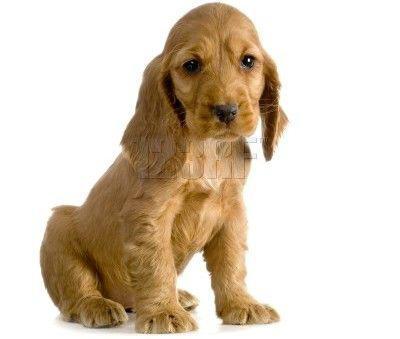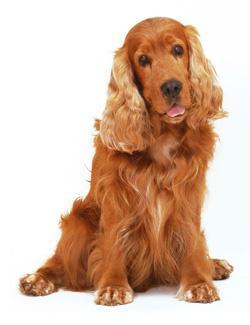The first image is the image on the left, the second image is the image on the right. Analyze the images presented: Is the assertion "There is one dog with its tongue out." valid? Answer yes or no. Yes. The first image is the image on the left, the second image is the image on the right. For the images shown, is this caption "A single dog tongue can be seen in the image on the left" true? Answer yes or no. No. 